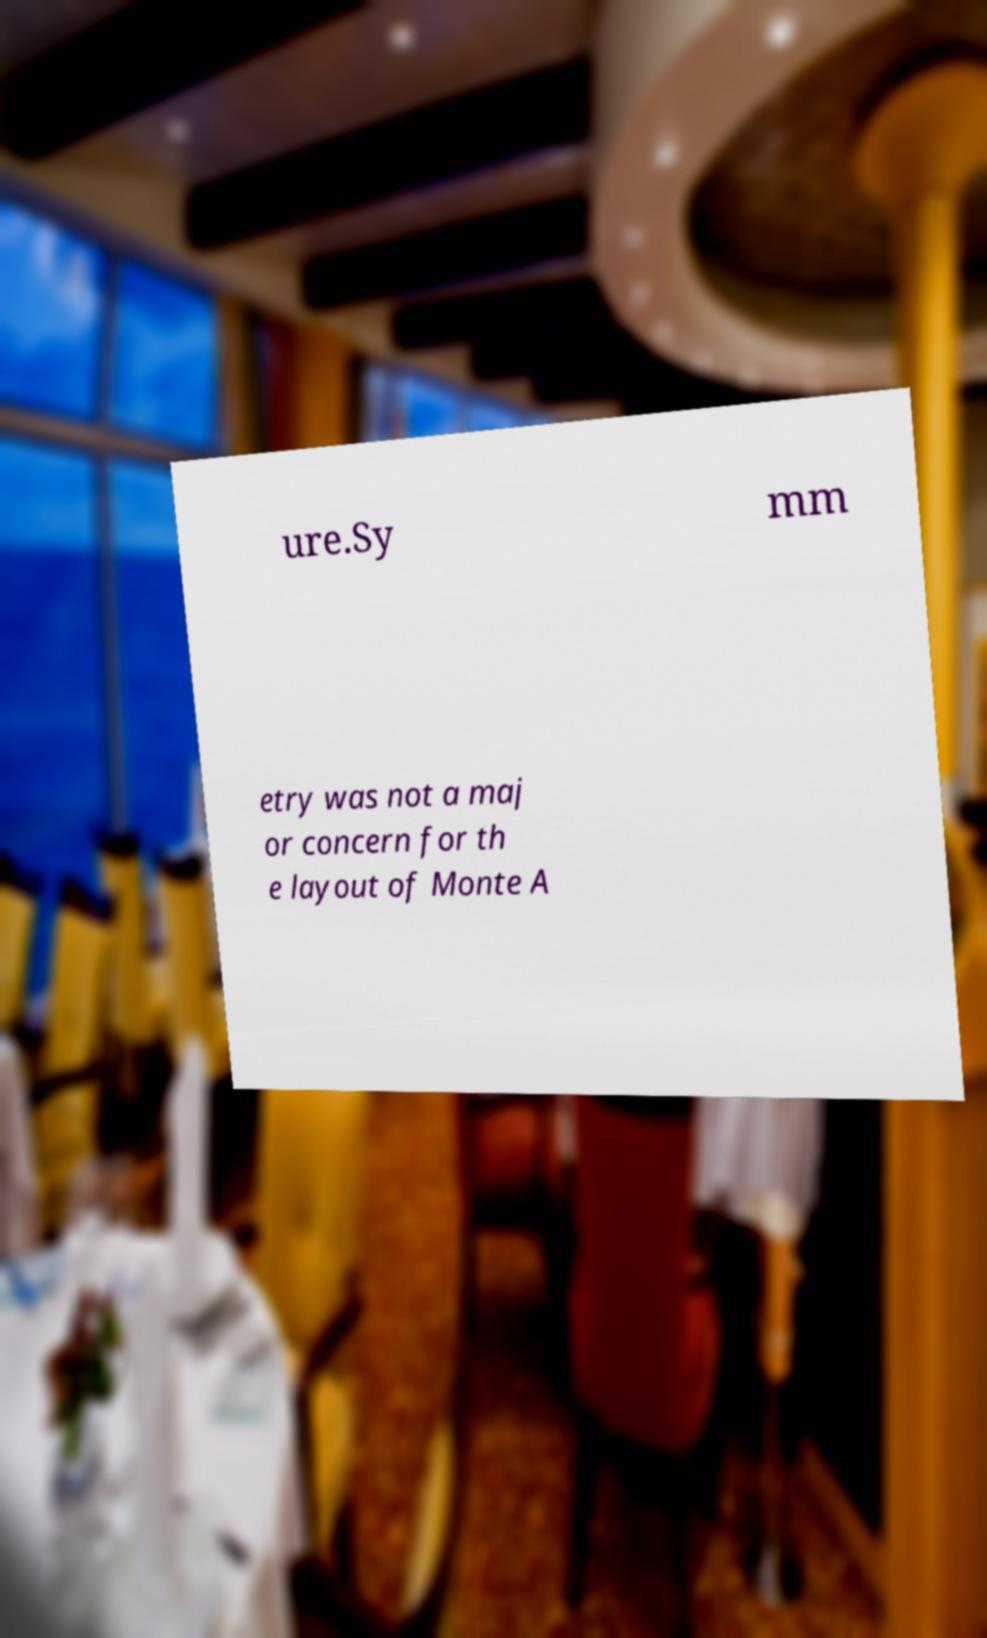Please read and relay the text visible in this image. What does it say? ure.Sy mm etry was not a maj or concern for th e layout of Monte A 